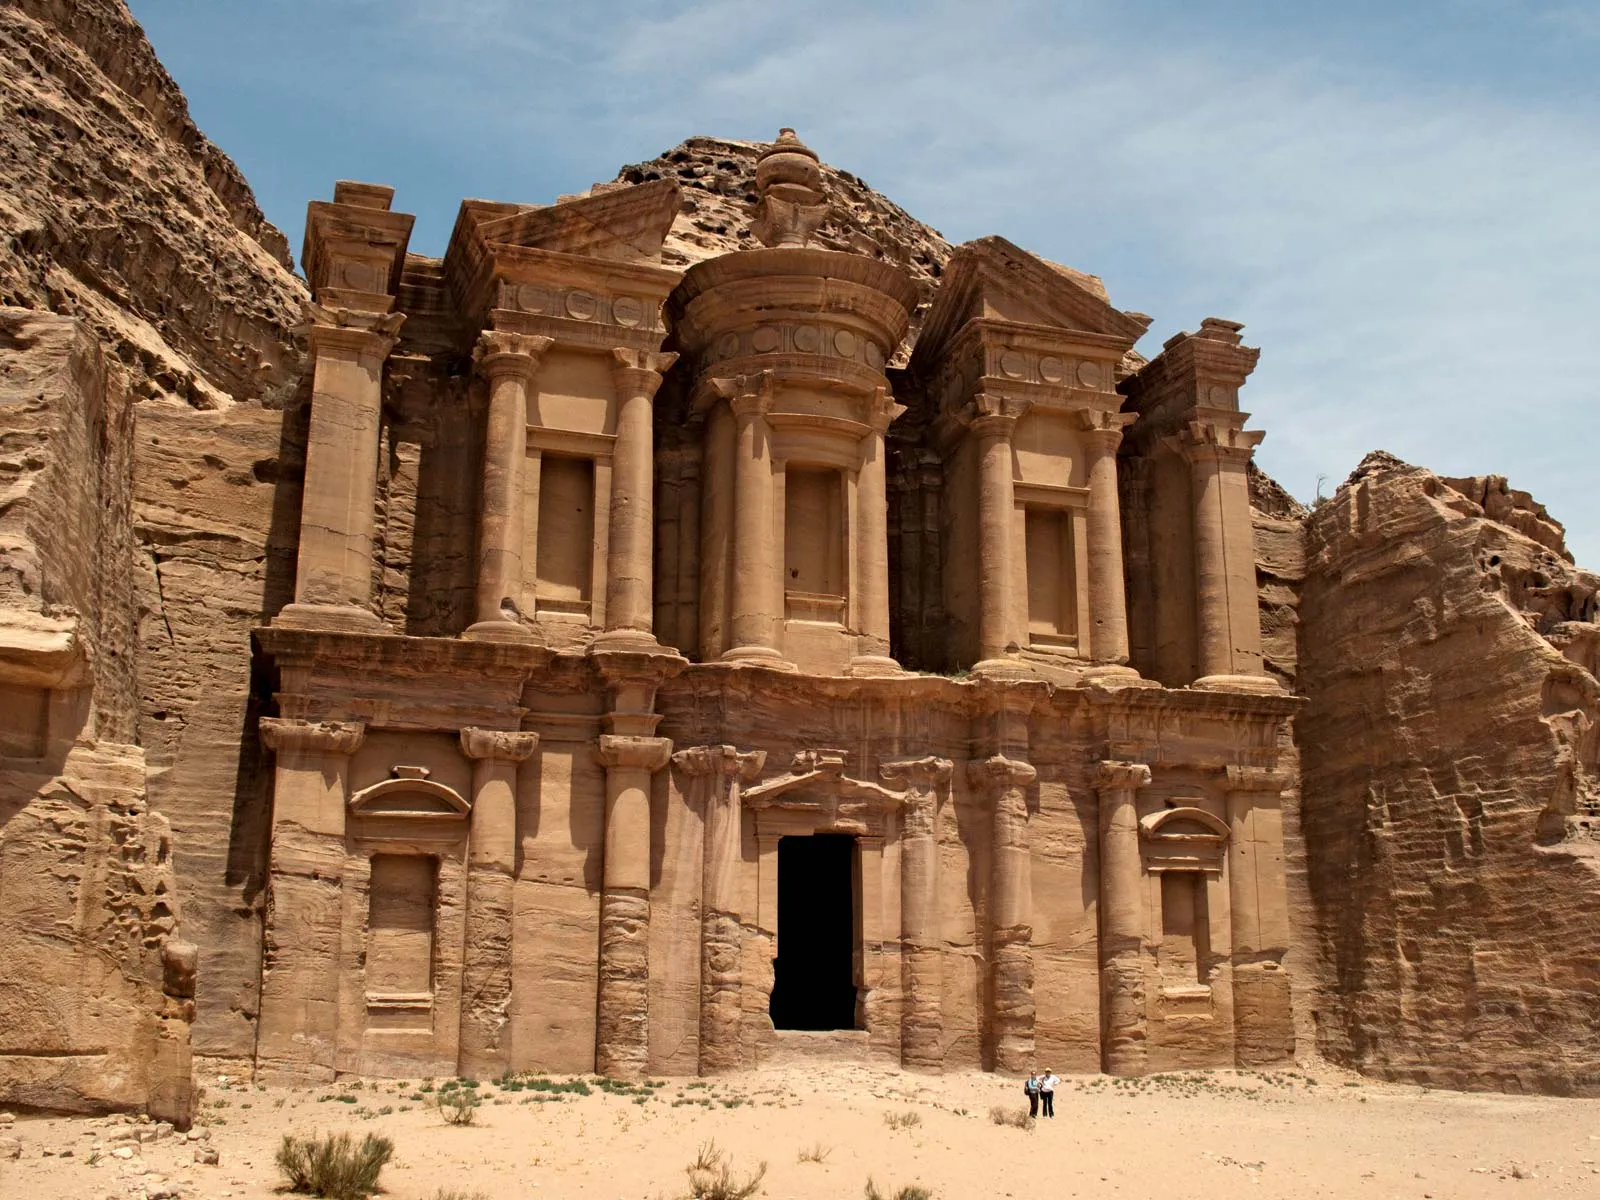How has the natural environment shaped the construction and preservation of the Monastery? The natural environment, consisting primarily of sandstone cliffs, has played a vital role in both the construction and preservation of the Monastery at Petra. The Nabateans utilized the inherent properties of sandstone, which is relatively soft and easy to carve but hardens upon exposure to air. This allowed for the detailed sculptures seen on the facade. However, the same material also poses a challenge for preservation as sandstone is prone to erosion by wind and rain, impacting the finer architectural details over centuries. 